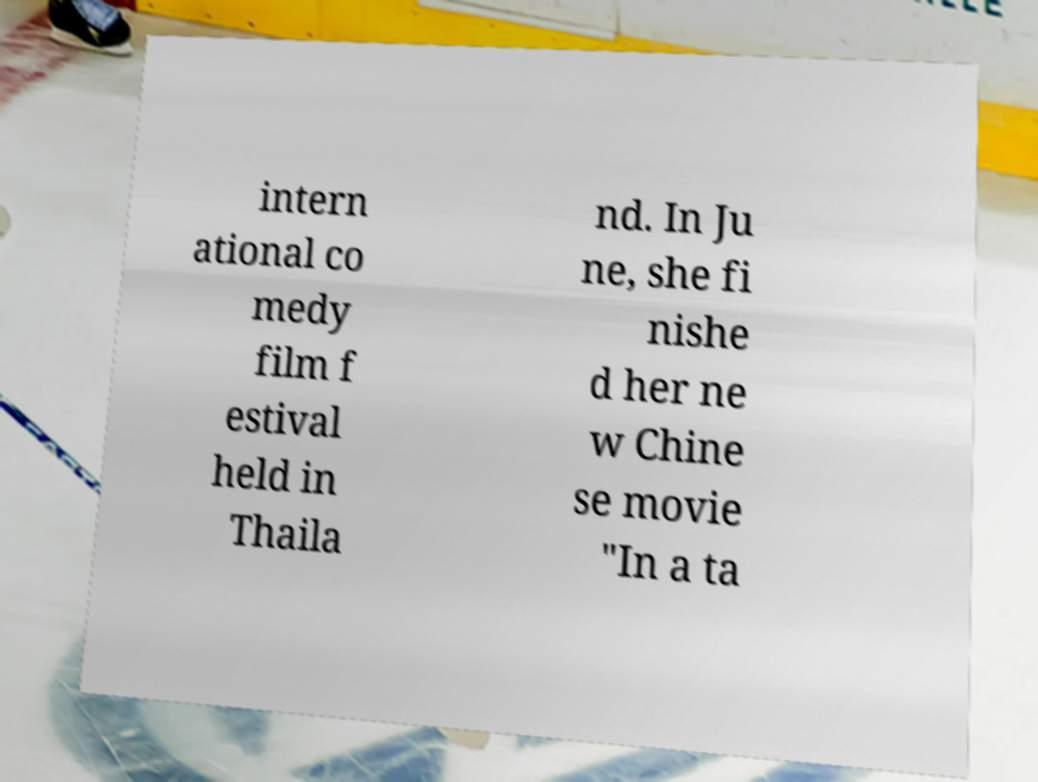There's text embedded in this image that I need extracted. Can you transcribe it verbatim? intern ational co medy film f estival held in Thaila nd. In Ju ne, she fi nishe d her ne w Chine se movie "In a ta 